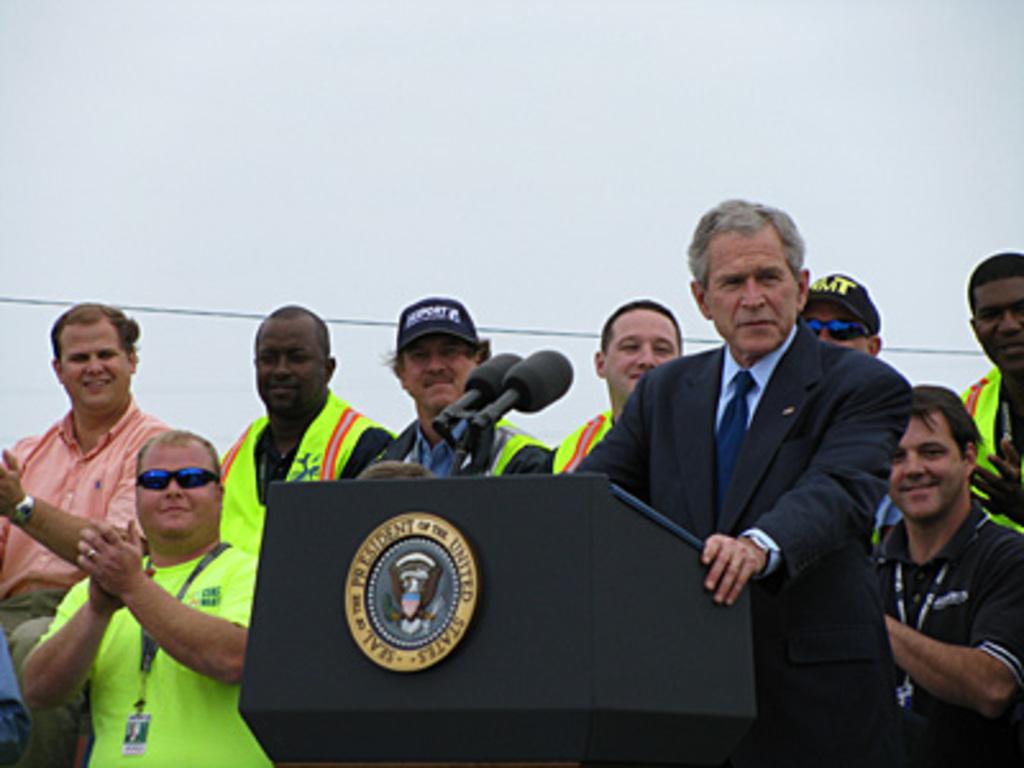In one or two sentences, can you explain what this image depicts? In this picture, we can see a few people, and among them a person is resting his hands on podium, we can see microphones, wire, and we can see the background. 